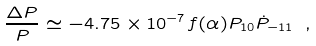Convert formula to latex. <formula><loc_0><loc_0><loc_500><loc_500>\frac { \Delta P } { P } \simeq - 4 . 7 5 \times 1 0 ^ { - 7 } f ( \alpha ) P _ { 1 0 } \dot { P } _ { - 1 1 } \ ,</formula> 